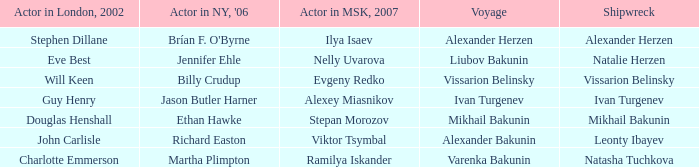Who was the 2007 actor from Moscow for the shipwreck of Leonty Ibayev? Viktor Tsymbal. 